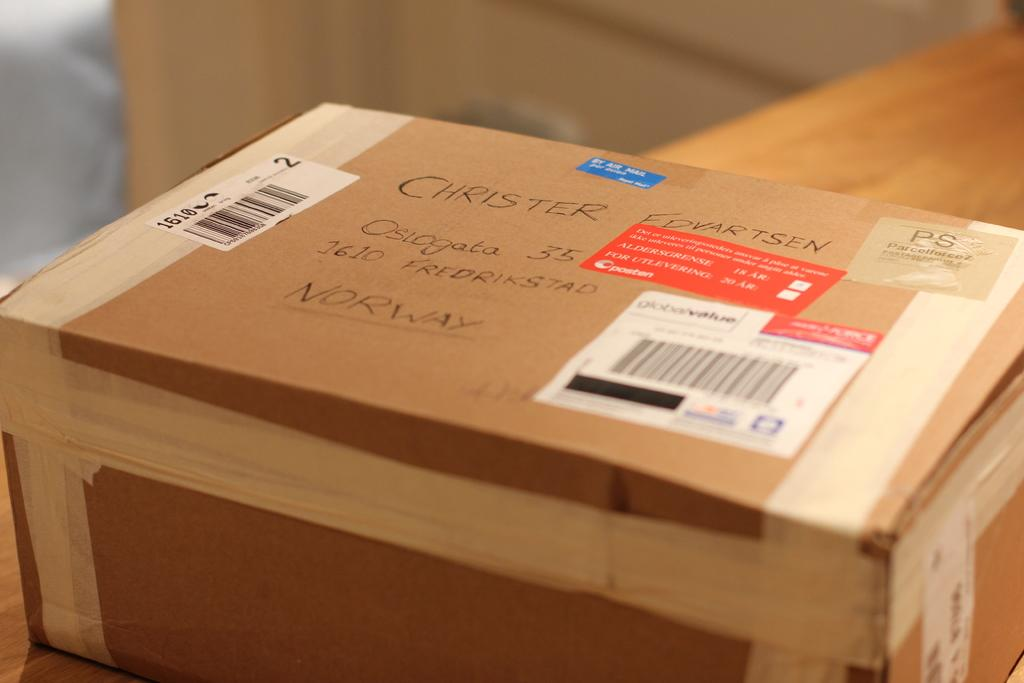<image>
Share a concise interpretation of the image provided. A package is adressed to Christer Fdvartsen in Norway. 